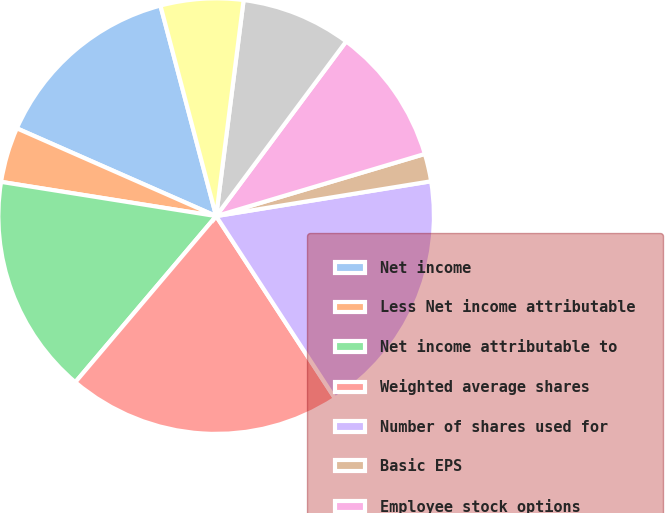<chart> <loc_0><loc_0><loc_500><loc_500><pie_chart><fcel>Net income<fcel>Less Net income attributable<fcel>Net income attributable to<fcel>Weighted average shares<fcel>Number of shares used for<fcel>Basic EPS<fcel>Employee stock options<fcel>RSUs<fcel>Shares subject to repurchase<nl><fcel>14.28%<fcel>4.09%<fcel>16.32%<fcel>20.39%<fcel>18.36%<fcel>2.05%<fcel>10.21%<fcel>8.17%<fcel>6.13%<nl></chart> 